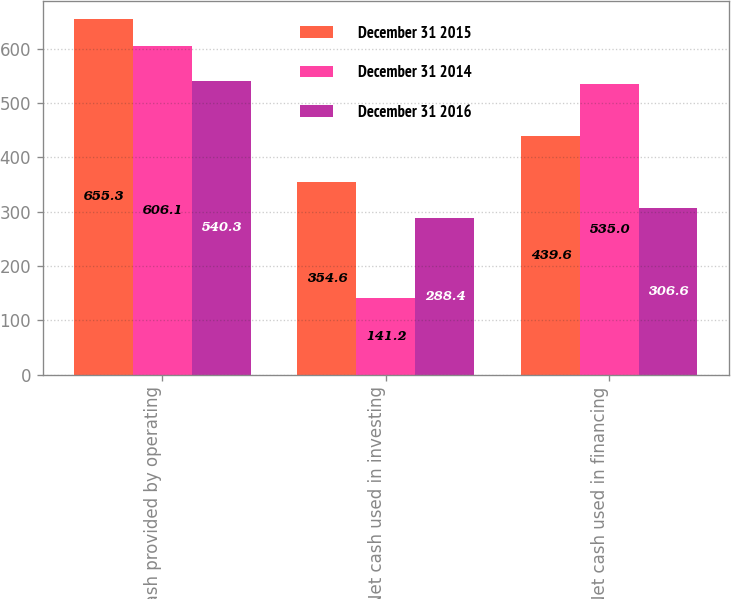Convert chart. <chart><loc_0><loc_0><loc_500><loc_500><stacked_bar_chart><ecel><fcel>Net cash provided by operating<fcel>Net cash used in investing<fcel>Net cash used in financing<nl><fcel>December 31 2015<fcel>655.3<fcel>354.6<fcel>439.6<nl><fcel>December 31 2014<fcel>606.1<fcel>141.2<fcel>535<nl><fcel>December 31 2016<fcel>540.3<fcel>288.4<fcel>306.6<nl></chart> 